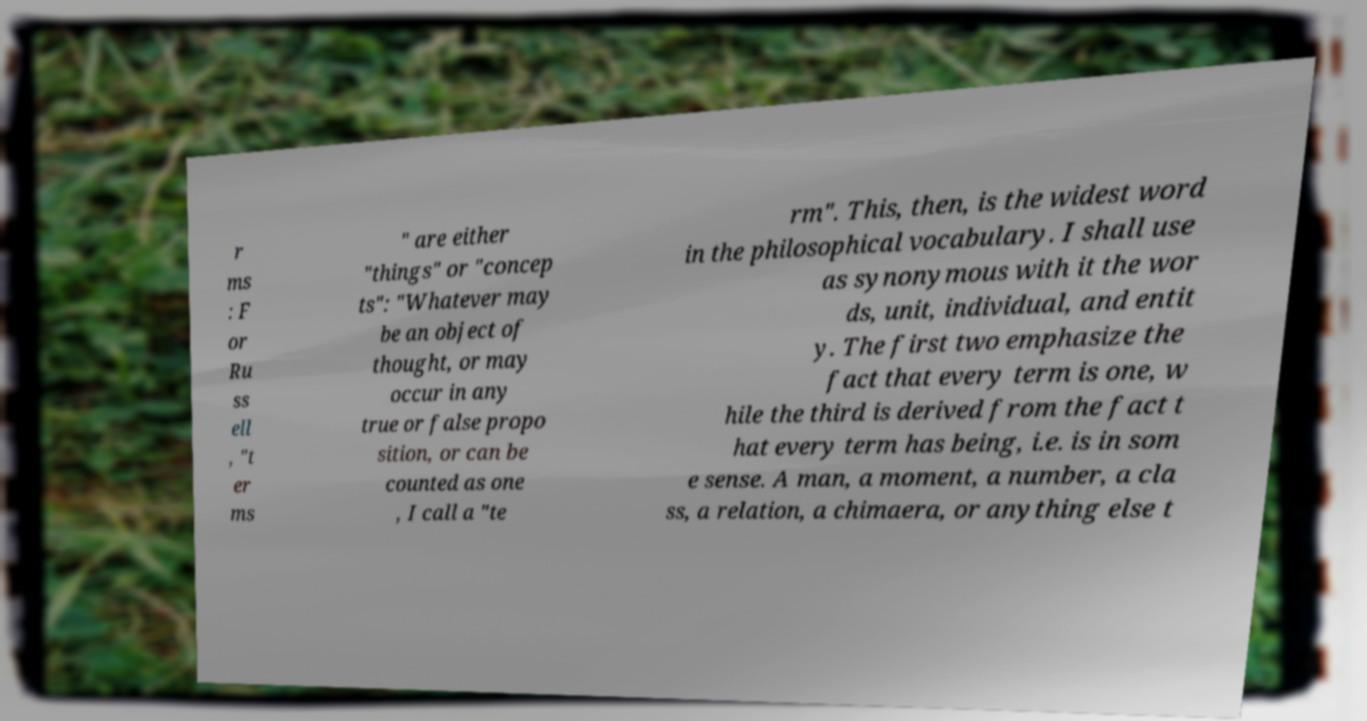Please identify and transcribe the text found in this image. r ms : F or Ru ss ell , "t er ms " are either "things" or "concep ts": "Whatever may be an object of thought, or may occur in any true or false propo sition, or can be counted as one , I call a "te rm". This, then, is the widest word in the philosophical vocabulary. I shall use as synonymous with it the wor ds, unit, individual, and entit y. The first two emphasize the fact that every term is one, w hile the third is derived from the fact t hat every term has being, i.e. is in som e sense. A man, a moment, a number, a cla ss, a relation, a chimaera, or anything else t 